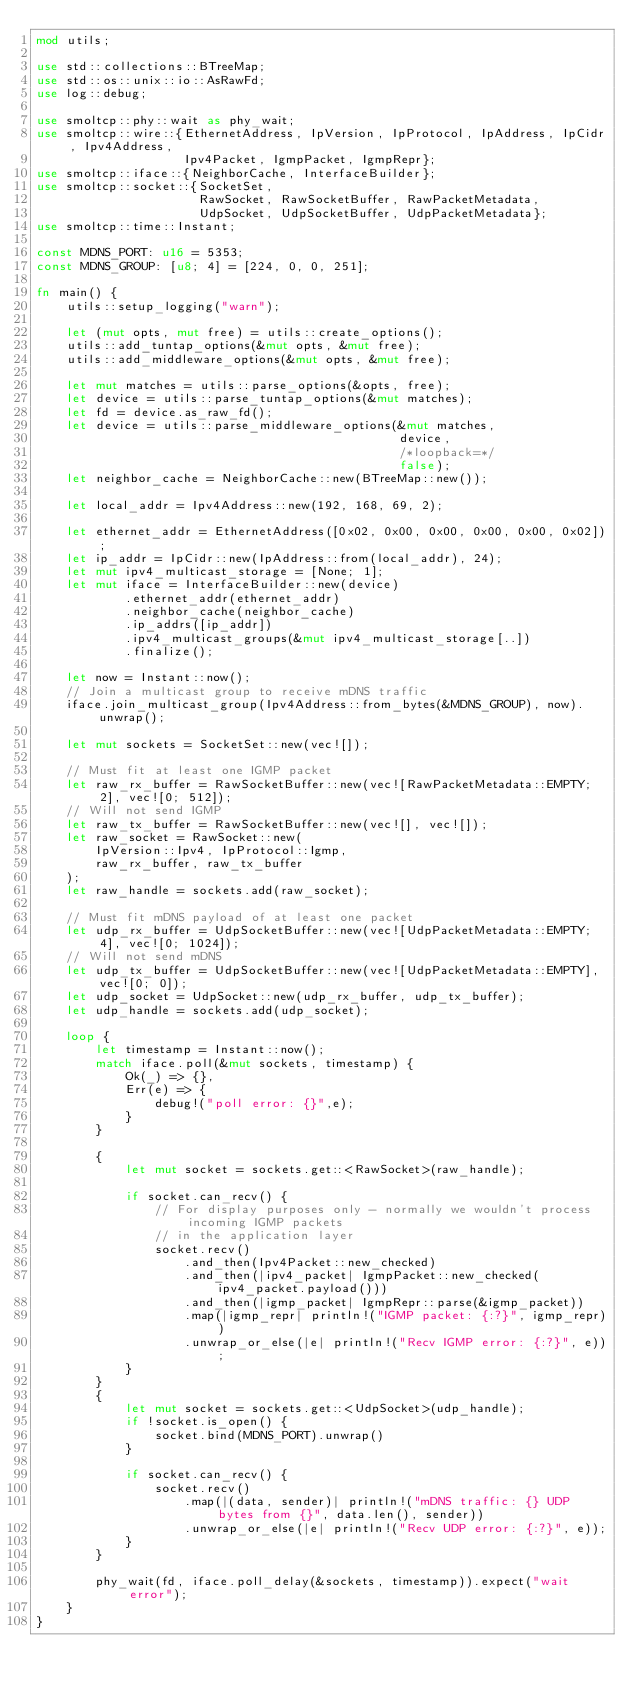Convert code to text. <code><loc_0><loc_0><loc_500><loc_500><_Rust_>mod utils;

use std::collections::BTreeMap;
use std::os::unix::io::AsRawFd;
use log::debug;

use smoltcp::phy::wait as phy_wait;
use smoltcp::wire::{EthernetAddress, IpVersion, IpProtocol, IpAddress, IpCidr, Ipv4Address,
                    Ipv4Packet, IgmpPacket, IgmpRepr};
use smoltcp::iface::{NeighborCache, InterfaceBuilder};
use smoltcp::socket::{SocketSet,
                      RawSocket, RawSocketBuffer, RawPacketMetadata,
                      UdpSocket, UdpSocketBuffer, UdpPacketMetadata};
use smoltcp::time::Instant;

const MDNS_PORT: u16 = 5353;
const MDNS_GROUP: [u8; 4] = [224, 0, 0, 251];

fn main() {
    utils::setup_logging("warn");

    let (mut opts, mut free) = utils::create_options();
    utils::add_tuntap_options(&mut opts, &mut free);
    utils::add_middleware_options(&mut opts, &mut free);

    let mut matches = utils::parse_options(&opts, free);
    let device = utils::parse_tuntap_options(&mut matches);
    let fd = device.as_raw_fd();
    let device = utils::parse_middleware_options(&mut matches,
                                                 device,
                                                 /*loopback=*/
                                                 false);
    let neighbor_cache = NeighborCache::new(BTreeMap::new());

    let local_addr = Ipv4Address::new(192, 168, 69, 2);

    let ethernet_addr = EthernetAddress([0x02, 0x00, 0x00, 0x00, 0x00, 0x02]);
    let ip_addr = IpCidr::new(IpAddress::from(local_addr), 24);
    let mut ipv4_multicast_storage = [None; 1];
    let mut iface = InterfaceBuilder::new(device)
            .ethernet_addr(ethernet_addr)
            .neighbor_cache(neighbor_cache)
            .ip_addrs([ip_addr])
            .ipv4_multicast_groups(&mut ipv4_multicast_storage[..])
            .finalize();

    let now = Instant::now();
    // Join a multicast group to receive mDNS traffic
    iface.join_multicast_group(Ipv4Address::from_bytes(&MDNS_GROUP), now).unwrap();

    let mut sockets = SocketSet::new(vec![]);

    // Must fit at least one IGMP packet
    let raw_rx_buffer = RawSocketBuffer::new(vec![RawPacketMetadata::EMPTY; 2], vec![0; 512]);
    // Will not send IGMP
    let raw_tx_buffer = RawSocketBuffer::new(vec![], vec![]);
    let raw_socket = RawSocket::new(
        IpVersion::Ipv4, IpProtocol::Igmp,
        raw_rx_buffer, raw_tx_buffer
    );
    let raw_handle = sockets.add(raw_socket);

    // Must fit mDNS payload of at least one packet
    let udp_rx_buffer = UdpSocketBuffer::new(vec![UdpPacketMetadata::EMPTY; 4], vec![0; 1024]);
    // Will not send mDNS
    let udp_tx_buffer = UdpSocketBuffer::new(vec![UdpPacketMetadata::EMPTY], vec![0; 0]);
    let udp_socket = UdpSocket::new(udp_rx_buffer, udp_tx_buffer);
    let udp_handle = sockets.add(udp_socket);

    loop {
        let timestamp = Instant::now();
        match iface.poll(&mut sockets, timestamp) {
            Ok(_) => {},
            Err(e) => {
                debug!("poll error: {}",e);
            }
        }

        {
            let mut socket = sockets.get::<RawSocket>(raw_handle);

            if socket.can_recv() {
                // For display purposes only - normally we wouldn't process incoming IGMP packets
                // in the application layer
                socket.recv()
                    .and_then(Ipv4Packet::new_checked)
                    .and_then(|ipv4_packet| IgmpPacket::new_checked(ipv4_packet.payload()))
                    .and_then(|igmp_packet| IgmpRepr::parse(&igmp_packet))
                    .map(|igmp_repr| println!("IGMP packet: {:?}", igmp_repr))
                    .unwrap_or_else(|e| println!("Recv IGMP error: {:?}", e));
            }
        }
        {
            let mut socket = sockets.get::<UdpSocket>(udp_handle);
            if !socket.is_open() {
                socket.bind(MDNS_PORT).unwrap()
            }

            if socket.can_recv() {
                socket.recv()
                    .map(|(data, sender)| println!("mDNS traffic: {} UDP bytes from {}", data.len(), sender))
                    .unwrap_or_else(|e| println!("Recv UDP error: {:?}", e));
            }
        }

        phy_wait(fd, iface.poll_delay(&sockets, timestamp)).expect("wait error");
    }
}
</code> 